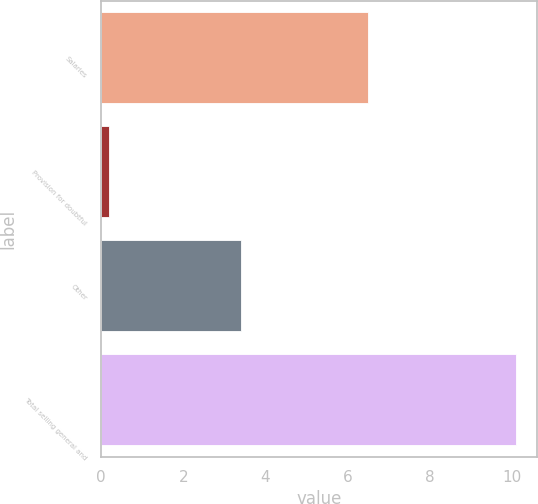<chart> <loc_0><loc_0><loc_500><loc_500><bar_chart><fcel>Salaries<fcel>Provision for doubtful<fcel>Other<fcel>Total selling general and<nl><fcel>6.5<fcel>0.2<fcel>3.4<fcel>10.1<nl></chart> 